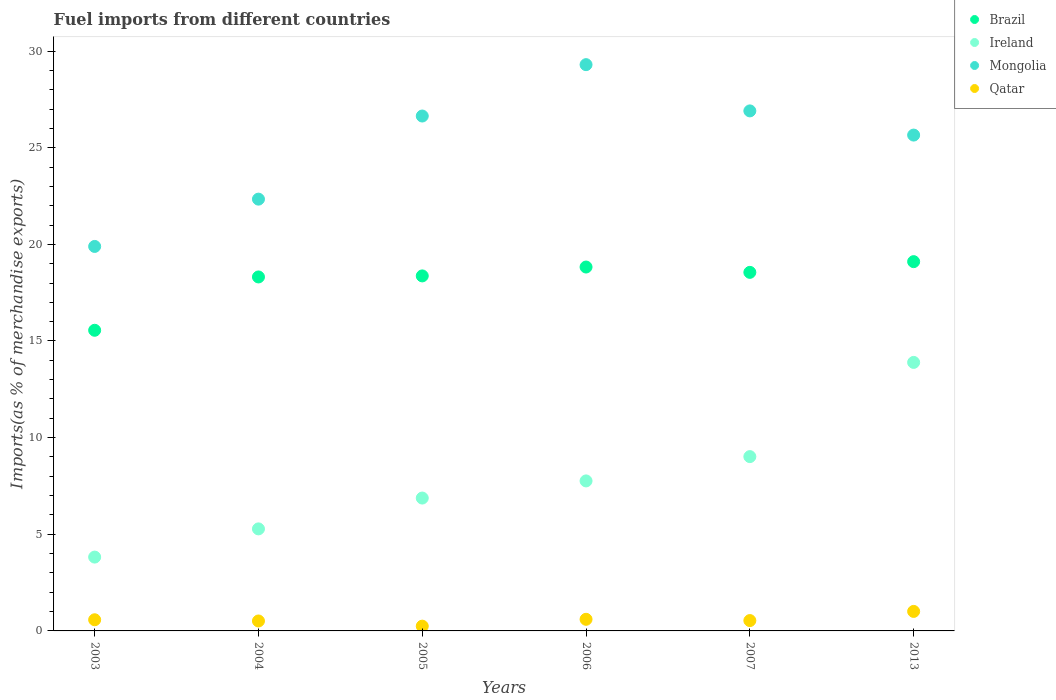How many different coloured dotlines are there?
Offer a terse response. 4. What is the percentage of imports to different countries in Mongolia in 2003?
Keep it short and to the point. 19.89. Across all years, what is the maximum percentage of imports to different countries in Brazil?
Ensure brevity in your answer.  19.1. Across all years, what is the minimum percentage of imports to different countries in Qatar?
Offer a terse response. 0.25. In which year was the percentage of imports to different countries in Ireland maximum?
Keep it short and to the point. 2013. In which year was the percentage of imports to different countries in Qatar minimum?
Provide a short and direct response. 2005. What is the total percentage of imports to different countries in Brazil in the graph?
Provide a succinct answer. 108.72. What is the difference between the percentage of imports to different countries in Mongolia in 2004 and that in 2005?
Make the answer very short. -4.3. What is the difference between the percentage of imports to different countries in Brazil in 2013 and the percentage of imports to different countries in Ireland in 2007?
Offer a very short reply. 10.09. What is the average percentage of imports to different countries in Qatar per year?
Your response must be concise. 0.58. In the year 2007, what is the difference between the percentage of imports to different countries in Brazil and percentage of imports to different countries in Mongolia?
Your answer should be very brief. -8.35. In how many years, is the percentage of imports to different countries in Ireland greater than 9 %?
Make the answer very short. 2. What is the ratio of the percentage of imports to different countries in Qatar in 2003 to that in 2005?
Ensure brevity in your answer.  2.34. Is the percentage of imports to different countries in Mongolia in 2005 less than that in 2006?
Provide a succinct answer. Yes. Is the difference between the percentage of imports to different countries in Brazil in 2003 and 2004 greater than the difference between the percentage of imports to different countries in Mongolia in 2003 and 2004?
Provide a short and direct response. No. What is the difference between the highest and the second highest percentage of imports to different countries in Qatar?
Your answer should be very brief. 0.41. What is the difference between the highest and the lowest percentage of imports to different countries in Mongolia?
Ensure brevity in your answer.  9.41. Is the sum of the percentage of imports to different countries in Qatar in 2004 and 2005 greater than the maximum percentage of imports to different countries in Brazil across all years?
Keep it short and to the point. No. Does the percentage of imports to different countries in Mongolia monotonically increase over the years?
Give a very brief answer. No. Is the percentage of imports to different countries in Ireland strictly greater than the percentage of imports to different countries in Qatar over the years?
Provide a short and direct response. Yes. Is the percentage of imports to different countries in Qatar strictly less than the percentage of imports to different countries in Mongolia over the years?
Provide a short and direct response. Yes. How many dotlines are there?
Offer a terse response. 4. Are the values on the major ticks of Y-axis written in scientific E-notation?
Provide a succinct answer. No. Does the graph contain grids?
Ensure brevity in your answer.  No. How many legend labels are there?
Offer a terse response. 4. How are the legend labels stacked?
Make the answer very short. Vertical. What is the title of the graph?
Ensure brevity in your answer.  Fuel imports from different countries. What is the label or title of the Y-axis?
Give a very brief answer. Imports(as % of merchandise exports). What is the Imports(as % of merchandise exports) of Brazil in 2003?
Give a very brief answer. 15.55. What is the Imports(as % of merchandise exports) in Ireland in 2003?
Make the answer very short. 3.82. What is the Imports(as % of merchandise exports) in Mongolia in 2003?
Your response must be concise. 19.89. What is the Imports(as % of merchandise exports) in Qatar in 2003?
Provide a succinct answer. 0.58. What is the Imports(as % of merchandise exports) of Brazil in 2004?
Your answer should be very brief. 18.31. What is the Imports(as % of merchandise exports) of Ireland in 2004?
Your answer should be compact. 5.28. What is the Imports(as % of merchandise exports) in Mongolia in 2004?
Your answer should be compact. 22.34. What is the Imports(as % of merchandise exports) in Qatar in 2004?
Provide a short and direct response. 0.51. What is the Imports(as % of merchandise exports) in Brazil in 2005?
Ensure brevity in your answer.  18.37. What is the Imports(as % of merchandise exports) in Ireland in 2005?
Your response must be concise. 6.87. What is the Imports(as % of merchandise exports) in Mongolia in 2005?
Offer a terse response. 26.64. What is the Imports(as % of merchandise exports) in Qatar in 2005?
Offer a very short reply. 0.25. What is the Imports(as % of merchandise exports) in Brazil in 2006?
Your answer should be very brief. 18.83. What is the Imports(as % of merchandise exports) in Ireland in 2006?
Your response must be concise. 7.76. What is the Imports(as % of merchandise exports) of Mongolia in 2006?
Give a very brief answer. 29.3. What is the Imports(as % of merchandise exports) in Qatar in 2006?
Ensure brevity in your answer.  0.6. What is the Imports(as % of merchandise exports) of Brazil in 2007?
Your answer should be compact. 18.55. What is the Imports(as % of merchandise exports) of Ireland in 2007?
Keep it short and to the point. 9.02. What is the Imports(as % of merchandise exports) of Mongolia in 2007?
Your answer should be compact. 26.9. What is the Imports(as % of merchandise exports) in Qatar in 2007?
Give a very brief answer. 0.54. What is the Imports(as % of merchandise exports) in Brazil in 2013?
Make the answer very short. 19.1. What is the Imports(as % of merchandise exports) in Ireland in 2013?
Make the answer very short. 13.89. What is the Imports(as % of merchandise exports) of Mongolia in 2013?
Keep it short and to the point. 25.65. What is the Imports(as % of merchandise exports) of Qatar in 2013?
Your answer should be very brief. 1.01. Across all years, what is the maximum Imports(as % of merchandise exports) of Brazil?
Offer a very short reply. 19.1. Across all years, what is the maximum Imports(as % of merchandise exports) in Ireland?
Make the answer very short. 13.89. Across all years, what is the maximum Imports(as % of merchandise exports) in Mongolia?
Your answer should be very brief. 29.3. Across all years, what is the maximum Imports(as % of merchandise exports) of Qatar?
Offer a terse response. 1.01. Across all years, what is the minimum Imports(as % of merchandise exports) of Brazil?
Offer a very short reply. 15.55. Across all years, what is the minimum Imports(as % of merchandise exports) of Ireland?
Your response must be concise. 3.82. Across all years, what is the minimum Imports(as % of merchandise exports) of Mongolia?
Your answer should be very brief. 19.89. Across all years, what is the minimum Imports(as % of merchandise exports) of Qatar?
Ensure brevity in your answer.  0.25. What is the total Imports(as % of merchandise exports) in Brazil in the graph?
Give a very brief answer. 108.72. What is the total Imports(as % of merchandise exports) in Ireland in the graph?
Your answer should be very brief. 46.64. What is the total Imports(as % of merchandise exports) of Mongolia in the graph?
Offer a very short reply. 150.72. What is the total Imports(as % of merchandise exports) of Qatar in the graph?
Offer a terse response. 3.48. What is the difference between the Imports(as % of merchandise exports) in Brazil in 2003 and that in 2004?
Your answer should be very brief. -2.76. What is the difference between the Imports(as % of merchandise exports) of Ireland in 2003 and that in 2004?
Your response must be concise. -1.46. What is the difference between the Imports(as % of merchandise exports) in Mongolia in 2003 and that in 2004?
Provide a succinct answer. -2.45. What is the difference between the Imports(as % of merchandise exports) in Qatar in 2003 and that in 2004?
Your response must be concise. 0.06. What is the difference between the Imports(as % of merchandise exports) in Brazil in 2003 and that in 2005?
Your answer should be very brief. -2.81. What is the difference between the Imports(as % of merchandise exports) of Ireland in 2003 and that in 2005?
Offer a terse response. -3.05. What is the difference between the Imports(as % of merchandise exports) in Mongolia in 2003 and that in 2005?
Give a very brief answer. -6.75. What is the difference between the Imports(as % of merchandise exports) of Qatar in 2003 and that in 2005?
Offer a very short reply. 0.33. What is the difference between the Imports(as % of merchandise exports) of Brazil in 2003 and that in 2006?
Ensure brevity in your answer.  -3.27. What is the difference between the Imports(as % of merchandise exports) of Ireland in 2003 and that in 2006?
Provide a short and direct response. -3.94. What is the difference between the Imports(as % of merchandise exports) in Mongolia in 2003 and that in 2006?
Give a very brief answer. -9.41. What is the difference between the Imports(as % of merchandise exports) in Qatar in 2003 and that in 2006?
Provide a short and direct response. -0.02. What is the difference between the Imports(as % of merchandise exports) in Brazil in 2003 and that in 2007?
Offer a terse response. -3. What is the difference between the Imports(as % of merchandise exports) in Ireland in 2003 and that in 2007?
Provide a short and direct response. -5.2. What is the difference between the Imports(as % of merchandise exports) of Mongolia in 2003 and that in 2007?
Ensure brevity in your answer.  -7.01. What is the difference between the Imports(as % of merchandise exports) in Qatar in 2003 and that in 2007?
Ensure brevity in your answer.  0.04. What is the difference between the Imports(as % of merchandise exports) of Brazil in 2003 and that in 2013?
Give a very brief answer. -3.55. What is the difference between the Imports(as % of merchandise exports) of Ireland in 2003 and that in 2013?
Give a very brief answer. -10.07. What is the difference between the Imports(as % of merchandise exports) of Mongolia in 2003 and that in 2013?
Your answer should be very brief. -5.76. What is the difference between the Imports(as % of merchandise exports) of Qatar in 2003 and that in 2013?
Give a very brief answer. -0.43. What is the difference between the Imports(as % of merchandise exports) in Brazil in 2004 and that in 2005?
Give a very brief answer. -0.05. What is the difference between the Imports(as % of merchandise exports) in Ireland in 2004 and that in 2005?
Provide a short and direct response. -1.59. What is the difference between the Imports(as % of merchandise exports) of Mongolia in 2004 and that in 2005?
Ensure brevity in your answer.  -4.3. What is the difference between the Imports(as % of merchandise exports) of Qatar in 2004 and that in 2005?
Ensure brevity in your answer.  0.27. What is the difference between the Imports(as % of merchandise exports) in Brazil in 2004 and that in 2006?
Ensure brevity in your answer.  -0.51. What is the difference between the Imports(as % of merchandise exports) of Ireland in 2004 and that in 2006?
Keep it short and to the point. -2.48. What is the difference between the Imports(as % of merchandise exports) of Mongolia in 2004 and that in 2006?
Your response must be concise. -6.96. What is the difference between the Imports(as % of merchandise exports) of Qatar in 2004 and that in 2006?
Your response must be concise. -0.09. What is the difference between the Imports(as % of merchandise exports) in Brazil in 2004 and that in 2007?
Your answer should be compact. -0.24. What is the difference between the Imports(as % of merchandise exports) in Ireland in 2004 and that in 2007?
Offer a very short reply. -3.74. What is the difference between the Imports(as % of merchandise exports) of Mongolia in 2004 and that in 2007?
Your answer should be compact. -4.57. What is the difference between the Imports(as % of merchandise exports) of Qatar in 2004 and that in 2007?
Keep it short and to the point. -0.02. What is the difference between the Imports(as % of merchandise exports) of Brazil in 2004 and that in 2013?
Offer a terse response. -0.79. What is the difference between the Imports(as % of merchandise exports) of Ireland in 2004 and that in 2013?
Ensure brevity in your answer.  -8.61. What is the difference between the Imports(as % of merchandise exports) of Mongolia in 2004 and that in 2013?
Your answer should be very brief. -3.31. What is the difference between the Imports(as % of merchandise exports) in Qatar in 2004 and that in 2013?
Provide a succinct answer. -0.49. What is the difference between the Imports(as % of merchandise exports) of Brazil in 2005 and that in 2006?
Offer a very short reply. -0.46. What is the difference between the Imports(as % of merchandise exports) in Ireland in 2005 and that in 2006?
Provide a succinct answer. -0.89. What is the difference between the Imports(as % of merchandise exports) of Mongolia in 2005 and that in 2006?
Your answer should be very brief. -2.66. What is the difference between the Imports(as % of merchandise exports) of Qatar in 2005 and that in 2006?
Provide a short and direct response. -0.35. What is the difference between the Imports(as % of merchandise exports) in Brazil in 2005 and that in 2007?
Provide a succinct answer. -0.18. What is the difference between the Imports(as % of merchandise exports) in Ireland in 2005 and that in 2007?
Make the answer very short. -2.14. What is the difference between the Imports(as % of merchandise exports) of Mongolia in 2005 and that in 2007?
Provide a succinct answer. -0.27. What is the difference between the Imports(as % of merchandise exports) in Qatar in 2005 and that in 2007?
Make the answer very short. -0.29. What is the difference between the Imports(as % of merchandise exports) of Brazil in 2005 and that in 2013?
Offer a terse response. -0.74. What is the difference between the Imports(as % of merchandise exports) of Ireland in 2005 and that in 2013?
Provide a short and direct response. -7.02. What is the difference between the Imports(as % of merchandise exports) of Mongolia in 2005 and that in 2013?
Give a very brief answer. 0.99. What is the difference between the Imports(as % of merchandise exports) of Qatar in 2005 and that in 2013?
Provide a succinct answer. -0.76. What is the difference between the Imports(as % of merchandise exports) in Brazil in 2006 and that in 2007?
Offer a very short reply. 0.28. What is the difference between the Imports(as % of merchandise exports) in Ireland in 2006 and that in 2007?
Your response must be concise. -1.26. What is the difference between the Imports(as % of merchandise exports) in Mongolia in 2006 and that in 2007?
Ensure brevity in your answer.  2.39. What is the difference between the Imports(as % of merchandise exports) of Qatar in 2006 and that in 2007?
Your answer should be compact. 0.07. What is the difference between the Imports(as % of merchandise exports) in Brazil in 2006 and that in 2013?
Make the answer very short. -0.28. What is the difference between the Imports(as % of merchandise exports) in Ireland in 2006 and that in 2013?
Keep it short and to the point. -6.13. What is the difference between the Imports(as % of merchandise exports) of Mongolia in 2006 and that in 2013?
Your answer should be compact. 3.64. What is the difference between the Imports(as % of merchandise exports) in Qatar in 2006 and that in 2013?
Make the answer very short. -0.41. What is the difference between the Imports(as % of merchandise exports) in Brazil in 2007 and that in 2013?
Your response must be concise. -0.55. What is the difference between the Imports(as % of merchandise exports) in Ireland in 2007 and that in 2013?
Provide a succinct answer. -4.87. What is the difference between the Imports(as % of merchandise exports) of Mongolia in 2007 and that in 2013?
Provide a succinct answer. 1.25. What is the difference between the Imports(as % of merchandise exports) of Qatar in 2007 and that in 2013?
Offer a very short reply. -0.47. What is the difference between the Imports(as % of merchandise exports) of Brazil in 2003 and the Imports(as % of merchandise exports) of Ireland in 2004?
Your response must be concise. 10.28. What is the difference between the Imports(as % of merchandise exports) in Brazil in 2003 and the Imports(as % of merchandise exports) in Mongolia in 2004?
Ensure brevity in your answer.  -6.78. What is the difference between the Imports(as % of merchandise exports) of Brazil in 2003 and the Imports(as % of merchandise exports) of Qatar in 2004?
Give a very brief answer. 15.04. What is the difference between the Imports(as % of merchandise exports) in Ireland in 2003 and the Imports(as % of merchandise exports) in Mongolia in 2004?
Make the answer very short. -18.52. What is the difference between the Imports(as % of merchandise exports) in Ireland in 2003 and the Imports(as % of merchandise exports) in Qatar in 2004?
Give a very brief answer. 3.31. What is the difference between the Imports(as % of merchandise exports) in Mongolia in 2003 and the Imports(as % of merchandise exports) in Qatar in 2004?
Ensure brevity in your answer.  19.38. What is the difference between the Imports(as % of merchandise exports) in Brazil in 2003 and the Imports(as % of merchandise exports) in Ireland in 2005?
Offer a very short reply. 8.68. What is the difference between the Imports(as % of merchandise exports) of Brazil in 2003 and the Imports(as % of merchandise exports) of Mongolia in 2005?
Your answer should be very brief. -11.08. What is the difference between the Imports(as % of merchandise exports) of Brazil in 2003 and the Imports(as % of merchandise exports) of Qatar in 2005?
Ensure brevity in your answer.  15.31. What is the difference between the Imports(as % of merchandise exports) of Ireland in 2003 and the Imports(as % of merchandise exports) of Mongolia in 2005?
Your answer should be compact. -22.82. What is the difference between the Imports(as % of merchandise exports) of Ireland in 2003 and the Imports(as % of merchandise exports) of Qatar in 2005?
Make the answer very short. 3.57. What is the difference between the Imports(as % of merchandise exports) in Mongolia in 2003 and the Imports(as % of merchandise exports) in Qatar in 2005?
Provide a short and direct response. 19.65. What is the difference between the Imports(as % of merchandise exports) of Brazil in 2003 and the Imports(as % of merchandise exports) of Ireland in 2006?
Provide a succinct answer. 7.79. What is the difference between the Imports(as % of merchandise exports) in Brazil in 2003 and the Imports(as % of merchandise exports) in Mongolia in 2006?
Your answer should be very brief. -13.74. What is the difference between the Imports(as % of merchandise exports) in Brazil in 2003 and the Imports(as % of merchandise exports) in Qatar in 2006?
Offer a very short reply. 14.95. What is the difference between the Imports(as % of merchandise exports) in Ireland in 2003 and the Imports(as % of merchandise exports) in Mongolia in 2006?
Give a very brief answer. -25.48. What is the difference between the Imports(as % of merchandise exports) of Ireland in 2003 and the Imports(as % of merchandise exports) of Qatar in 2006?
Your answer should be very brief. 3.22. What is the difference between the Imports(as % of merchandise exports) in Mongolia in 2003 and the Imports(as % of merchandise exports) in Qatar in 2006?
Keep it short and to the point. 19.29. What is the difference between the Imports(as % of merchandise exports) of Brazil in 2003 and the Imports(as % of merchandise exports) of Ireland in 2007?
Your response must be concise. 6.54. What is the difference between the Imports(as % of merchandise exports) of Brazil in 2003 and the Imports(as % of merchandise exports) of Mongolia in 2007?
Offer a very short reply. -11.35. What is the difference between the Imports(as % of merchandise exports) in Brazil in 2003 and the Imports(as % of merchandise exports) in Qatar in 2007?
Keep it short and to the point. 15.02. What is the difference between the Imports(as % of merchandise exports) of Ireland in 2003 and the Imports(as % of merchandise exports) of Mongolia in 2007?
Your response must be concise. -23.08. What is the difference between the Imports(as % of merchandise exports) of Ireland in 2003 and the Imports(as % of merchandise exports) of Qatar in 2007?
Your answer should be compact. 3.28. What is the difference between the Imports(as % of merchandise exports) of Mongolia in 2003 and the Imports(as % of merchandise exports) of Qatar in 2007?
Keep it short and to the point. 19.36. What is the difference between the Imports(as % of merchandise exports) in Brazil in 2003 and the Imports(as % of merchandise exports) in Ireland in 2013?
Provide a succinct answer. 1.66. What is the difference between the Imports(as % of merchandise exports) in Brazil in 2003 and the Imports(as % of merchandise exports) in Mongolia in 2013?
Ensure brevity in your answer.  -10.1. What is the difference between the Imports(as % of merchandise exports) of Brazil in 2003 and the Imports(as % of merchandise exports) of Qatar in 2013?
Provide a short and direct response. 14.54. What is the difference between the Imports(as % of merchandise exports) in Ireland in 2003 and the Imports(as % of merchandise exports) in Mongolia in 2013?
Offer a terse response. -21.83. What is the difference between the Imports(as % of merchandise exports) of Ireland in 2003 and the Imports(as % of merchandise exports) of Qatar in 2013?
Offer a terse response. 2.81. What is the difference between the Imports(as % of merchandise exports) of Mongolia in 2003 and the Imports(as % of merchandise exports) of Qatar in 2013?
Ensure brevity in your answer.  18.88. What is the difference between the Imports(as % of merchandise exports) in Brazil in 2004 and the Imports(as % of merchandise exports) in Ireland in 2005?
Provide a short and direct response. 11.44. What is the difference between the Imports(as % of merchandise exports) in Brazil in 2004 and the Imports(as % of merchandise exports) in Mongolia in 2005?
Offer a terse response. -8.33. What is the difference between the Imports(as % of merchandise exports) of Brazil in 2004 and the Imports(as % of merchandise exports) of Qatar in 2005?
Give a very brief answer. 18.07. What is the difference between the Imports(as % of merchandise exports) in Ireland in 2004 and the Imports(as % of merchandise exports) in Mongolia in 2005?
Offer a very short reply. -21.36. What is the difference between the Imports(as % of merchandise exports) of Ireland in 2004 and the Imports(as % of merchandise exports) of Qatar in 2005?
Give a very brief answer. 5.03. What is the difference between the Imports(as % of merchandise exports) in Mongolia in 2004 and the Imports(as % of merchandise exports) in Qatar in 2005?
Ensure brevity in your answer.  22.09. What is the difference between the Imports(as % of merchandise exports) of Brazil in 2004 and the Imports(as % of merchandise exports) of Ireland in 2006?
Your response must be concise. 10.55. What is the difference between the Imports(as % of merchandise exports) in Brazil in 2004 and the Imports(as % of merchandise exports) in Mongolia in 2006?
Offer a very short reply. -10.98. What is the difference between the Imports(as % of merchandise exports) of Brazil in 2004 and the Imports(as % of merchandise exports) of Qatar in 2006?
Ensure brevity in your answer.  17.71. What is the difference between the Imports(as % of merchandise exports) of Ireland in 2004 and the Imports(as % of merchandise exports) of Mongolia in 2006?
Your answer should be very brief. -24.02. What is the difference between the Imports(as % of merchandise exports) in Ireland in 2004 and the Imports(as % of merchandise exports) in Qatar in 2006?
Ensure brevity in your answer.  4.68. What is the difference between the Imports(as % of merchandise exports) of Mongolia in 2004 and the Imports(as % of merchandise exports) of Qatar in 2006?
Your response must be concise. 21.74. What is the difference between the Imports(as % of merchandise exports) in Brazil in 2004 and the Imports(as % of merchandise exports) in Ireland in 2007?
Make the answer very short. 9.29. What is the difference between the Imports(as % of merchandise exports) of Brazil in 2004 and the Imports(as % of merchandise exports) of Mongolia in 2007?
Make the answer very short. -8.59. What is the difference between the Imports(as % of merchandise exports) in Brazil in 2004 and the Imports(as % of merchandise exports) in Qatar in 2007?
Offer a very short reply. 17.78. What is the difference between the Imports(as % of merchandise exports) of Ireland in 2004 and the Imports(as % of merchandise exports) of Mongolia in 2007?
Your answer should be very brief. -21.63. What is the difference between the Imports(as % of merchandise exports) in Ireland in 2004 and the Imports(as % of merchandise exports) in Qatar in 2007?
Ensure brevity in your answer.  4.74. What is the difference between the Imports(as % of merchandise exports) in Mongolia in 2004 and the Imports(as % of merchandise exports) in Qatar in 2007?
Your response must be concise. 21.8. What is the difference between the Imports(as % of merchandise exports) of Brazil in 2004 and the Imports(as % of merchandise exports) of Ireland in 2013?
Give a very brief answer. 4.42. What is the difference between the Imports(as % of merchandise exports) in Brazil in 2004 and the Imports(as % of merchandise exports) in Mongolia in 2013?
Provide a succinct answer. -7.34. What is the difference between the Imports(as % of merchandise exports) of Brazil in 2004 and the Imports(as % of merchandise exports) of Qatar in 2013?
Your answer should be very brief. 17.3. What is the difference between the Imports(as % of merchandise exports) in Ireland in 2004 and the Imports(as % of merchandise exports) in Mongolia in 2013?
Your answer should be very brief. -20.37. What is the difference between the Imports(as % of merchandise exports) of Ireland in 2004 and the Imports(as % of merchandise exports) of Qatar in 2013?
Offer a terse response. 4.27. What is the difference between the Imports(as % of merchandise exports) in Mongolia in 2004 and the Imports(as % of merchandise exports) in Qatar in 2013?
Provide a short and direct response. 21.33. What is the difference between the Imports(as % of merchandise exports) of Brazil in 2005 and the Imports(as % of merchandise exports) of Ireland in 2006?
Your response must be concise. 10.61. What is the difference between the Imports(as % of merchandise exports) in Brazil in 2005 and the Imports(as % of merchandise exports) in Mongolia in 2006?
Your response must be concise. -10.93. What is the difference between the Imports(as % of merchandise exports) of Brazil in 2005 and the Imports(as % of merchandise exports) of Qatar in 2006?
Your answer should be very brief. 17.77. What is the difference between the Imports(as % of merchandise exports) in Ireland in 2005 and the Imports(as % of merchandise exports) in Mongolia in 2006?
Offer a terse response. -22.42. What is the difference between the Imports(as % of merchandise exports) of Ireland in 2005 and the Imports(as % of merchandise exports) of Qatar in 2006?
Offer a terse response. 6.27. What is the difference between the Imports(as % of merchandise exports) of Mongolia in 2005 and the Imports(as % of merchandise exports) of Qatar in 2006?
Provide a succinct answer. 26.04. What is the difference between the Imports(as % of merchandise exports) of Brazil in 2005 and the Imports(as % of merchandise exports) of Ireland in 2007?
Your response must be concise. 9.35. What is the difference between the Imports(as % of merchandise exports) of Brazil in 2005 and the Imports(as % of merchandise exports) of Mongolia in 2007?
Offer a terse response. -8.54. What is the difference between the Imports(as % of merchandise exports) of Brazil in 2005 and the Imports(as % of merchandise exports) of Qatar in 2007?
Your answer should be compact. 17.83. What is the difference between the Imports(as % of merchandise exports) of Ireland in 2005 and the Imports(as % of merchandise exports) of Mongolia in 2007?
Provide a succinct answer. -20.03. What is the difference between the Imports(as % of merchandise exports) of Ireland in 2005 and the Imports(as % of merchandise exports) of Qatar in 2007?
Your response must be concise. 6.34. What is the difference between the Imports(as % of merchandise exports) of Mongolia in 2005 and the Imports(as % of merchandise exports) of Qatar in 2007?
Offer a very short reply. 26.1. What is the difference between the Imports(as % of merchandise exports) in Brazil in 2005 and the Imports(as % of merchandise exports) in Ireland in 2013?
Your answer should be very brief. 4.48. What is the difference between the Imports(as % of merchandise exports) in Brazil in 2005 and the Imports(as % of merchandise exports) in Mongolia in 2013?
Make the answer very short. -7.29. What is the difference between the Imports(as % of merchandise exports) in Brazil in 2005 and the Imports(as % of merchandise exports) in Qatar in 2013?
Make the answer very short. 17.36. What is the difference between the Imports(as % of merchandise exports) of Ireland in 2005 and the Imports(as % of merchandise exports) of Mongolia in 2013?
Your answer should be very brief. -18.78. What is the difference between the Imports(as % of merchandise exports) in Ireland in 2005 and the Imports(as % of merchandise exports) in Qatar in 2013?
Offer a very short reply. 5.86. What is the difference between the Imports(as % of merchandise exports) in Mongolia in 2005 and the Imports(as % of merchandise exports) in Qatar in 2013?
Your answer should be compact. 25.63. What is the difference between the Imports(as % of merchandise exports) in Brazil in 2006 and the Imports(as % of merchandise exports) in Ireland in 2007?
Provide a succinct answer. 9.81. What is the difference between the Imports(as % of merchandise exports) of Brazil in 2006 and the Imports(as % of merchandise exports) of Mongolia in 2007?
Keep it short and to the point. -8.08. What is the difference between the Imports(as % of merchandise exports) in Brazil in 2006 and the Imports(as % of merchandise exports) in Qatar in 2007?
Ensure brevity in your answer.  18.29. What is the difference between the Imports(as % of merchandise exports) in Ireland in 2006 and the Imports(as % of merchandise exports) in Mongolia in 2007?
Give a very brief answer. -19.14. What is the difference between the Imports(as % of merchandise exports) of Ireland in 2006 and the Imports(as % of merchandise exports) of Qatar in 2007?
Offer a very short reply. 7.22. What is the difference between the Imports(as % of merchandise exports) of Mongolia in 2006 and the Imports(as % of merchandise exports) of Qatar in 2007?
Provide a short and direct response. 28.76. What is the difference between the Imports(as % of merchandise exports) in Brazil in 2006 and the Imports(as % of merchandise exports) in Ireland in 2013?
Offer a very short reply. 4.93. What is the difference between the Imports(as % of merchandise exports) of Brazil in 2006 and the Imports(as % of merchandise exports) of Mongolia in 2013?
Make the answer very short. -6.83. What is the difference between the Imports(as % of merchandise exports) of Brazil in 2006 and the Imports(as % of merchandise exports) of Qatar in 2013?
Provide a succinct answer. 17.82. What is the difference between the Imports(as % of merchandise exports) in Ireland in 2006 and the Imports(as % of merchandise exports) in Mongolia in 2013?
Give a very brief answer. -17.89. What is the difference between the Imports(as % of merchandise exports) in Ireland in 2006 and the Imports(as % of merchandise exports) in Qatar in 2013?
Make the answer very short. 6.75. What is the difference between the Imports(as % of merchandise exports) of Mongolia in 2006 and the Imports(as % of merchandise exports) of Qatar in 2013?
Make the answer very short. 28.29. What is the difference between the Imports(as % of merchandise exports) of Brazil in 2007 and the Imports(as % of merchandise exports) of Ireland in 2013?
Ensure brevity in your answer.  4.66. What is the difference between the Imports(as % of merchandise exports) of Brazil in 2007 and the Imports(as % of merchandise exports) of Mongolia in 2013?
Make the answer very short. -7.1. What is the difference between the Imports(as % of merchandise exports) of Brazil in 2007 and the Imports(as % of merchandise exports) of Qatar in 2013?
Provide a succinct answer. 17.54. What is the difference between the Imports(as % of merchandise exports) of Ireland in 2007 and the Imports(as % of merchandise exports) of Mongolia in 2013?
Make the answer very short. -16.63. What is the difference between the Imports(as % of merchandise exports) of Ireland in 2007 and the Imports(as % of merchandise exports) of Qatar in 2013?
Provide a short and direct response. 8.01. What is the difference between the Imports(as % of merchandise exports) of Mongolia in 2007 and the Imports(as % of merchandise exports) of Qatar in 2013?
Your answer should be very brief. 25.89. What is the average Imports(as % of merchandise exports) in Brazil per year?
Provide a succinct answer. 18.12. What is the average Imports(as % of merchandise exports) of Ireland per year?
Offer a terse response. 7.77. What is the average Imports(as % of merchandise exports) in Mongolia per year?
Your answer should be compact. 25.12. What is the average Imports(as % of merchandise exports) of Qatar per year?
Your answer should be very brief. 0.58. In the year 2003, what is the difference between the Imports(as % of merchandise exports) in Brazil and Imports(as % of merchandise exports) in Ireland?
Your answer should be very brief. 11.73. In the year 2003, what is the difference between the Imports(as % of merchandise exports) in Brazil and Imports(as % of merchandise exports) in Mongolia?
Make the answer very short. -4.34. In the year 2003, what is the difference between the Imports(as % of merchandise exports) of Brazil and Imports(as % of merchandise exports) of Qatar?
Give a very brief answer. 14.98. In the year 2003, what is the difference between the Imports(as % of merchandise exports) in Ireland and Imports(as % of merchandise exports) in Mongolia?
Make the answer very short. -16.07. In the year 2003, what is the difference between the Imports(as % of merchandise exports) in Ireland and Imports(as % of merchandise exports) in Qatar?
Keep it short and to the point. 3.24. In the year 2003, what is the difference between the Imports(as % of merchandise exports) in Mongolia and Imports(as % of merchandise exports) in Qatar?
Offer a very short reply. 19.31. In the year 2004, what is the difference between the Imports(as % of merchandise exports) in Brazil and Imports(as % of merchandise exports) in Ireland?
Ensure brevity in your answer.  13.03. In the year 2004, what is the difference between the Imports(as % of merchandise exports) of Brazil and Imports(as % of merchandise exports) of Mongolia?
Make the answer very short. -4.03. In the year 2004, what is the difference between the Imports(as % of merchandise exports) of Brazil and Imports(as % of merchandise exports) of Qatar?
Give a very brief answer. 17.8. In the year 2004, what is the difference between the Imports(as % of merchandise exports) in Ireland and Imports(as % of merchandise exports) in Mongolia?
Keep it short and to the point. -17.06. In the year 2004, what is the difference between the Imports(as % of merchandise exports) of Ireland and Imports(as % of merchandise exports) of Qatar?
Make the answer very short. 4.76. In the year 2004, what is the difference between the Imports(as % of merchandise exports) of Mongolia and Imports(as % of merchandise exports) of Qatar?
Ensure brevity in your answer.  21.82. In the year 2005, what is the difference between the Imports(as % of merchandise exports) of Brazil and Imports(as % of merchandise exports) of Ireland?
Your answer should be very brief. 11.49. In the year 2005, what is the difference between the Imports(as % of merchandise exports) in Brazil and Imports(as % of merchandise exports) in Mongolia?
Your answer should be very brief. -8.27. In the year 2005, what is the difference between the Imports(as % of merchandise exports) of Brazil and Imports(as % of merchandise exports) of Qatar?
Keep it short and to the point. 18.12. In the year 2005, what is the difference between the Imports(as % of merchandise exports) in Ireland and Imports(as % of merchandise exports) in Mongolia?
Offer a very short reply. -19.76. In the year 2005, what is the difference between the Imports(as % of merchandise exports) in Ireland and Imports(as % of merchandise exports) in Qatar?
Ensure brevity in your answer.  6.63. In the year 2005, what is the difference between the Imports(as % of merchandise exports) in Mongolia and Imports(as % of merchandise exports) in Qatar?
Offer a terse response. 26.39. In the year 2006, what is the difference between the Imports(as % of merchandise exports) of Brazil and Imports(as % of merchandise exports) of Ireland?
Offer a very short reply. 11.07. In the year 2006, what is the difference between the Imports(as % of merchandise exports) in Brazil and Imports(as % of merchandise exports) in Mongolia?
Provide a succinct answer. -10.47. In the year 2006, what is the difference between the Imports(as % of merchandise exports) in Brazil and Imports(as % of merchandise exports) in Qatar?
Your answer should be very brief. 18.23. In the year 2006, what is the difference between the Imports(as % of merchandise exports) in Ireland and Imports(as % of merchandise exports) in Mongolia?
Your answer should be compact. -21.54. In the year 2006, what is the difference between the Imports(as % of merchandise exports) of Ireland and Imports(as % of merchandise exports) of Qatar?
Give a very brief answer. 7.16. In the year 2006, what is the difference between the Imports(as % of merchandise exports) in Mongolia and Imports(as % of merchandise exports) in Qatar?
Give a very brief answer. 28.7. In the year 2007, what is the difference between the Imports(as % of merchandise exports) of Brazil and Imports(as % of merchandise exports) of Ireland?
Ensure brevity in your answer.  9.53. In the year 2007, what is the difference between the Imports(as % of merchandise exports) in Brazil and Imports(as % of merchandise exports) in Mongolia?
Provide a succinct answer. -8.35. In the year 2007, what is the difference between the Imports(as % of merchandise exports) in Brazil and Imports(as % of merchandise exports) in Qatar?
Your answer should be very brief. 18.01. In the year 2007, what is the difference between the Imports(as % of merchandise exports) in Ireland and Imports(as % of merchandise exports) in Mongolia?
Ensure brevity in your answer.  -17.89. In the year 2007, what is the difference between the Imports(as % of merchandise exports) of Ireland and Imports(as % of merchandise exports) of Qatar?
Offer a terse response. 8.48. In the year 2007, what is the difference between the Imports(as % of merchandise exports) in Mongolia and Imports(as % of merchandise exports) in Qatar?
Offer a very short reply. 26.37. In the year 2013, what is the difference between the Imports(as % of merchandise exports) of Brazil and Imports(as % of merchandise exports) of Ireland?
Ensure brevity in your answer.  5.21. In the year 2013, what is the difference between the Imports(as % of merchandise exports) in Brazil and Imports(as % of merchandise exports) in Mongolia?
Provide a short and direct response. -6.55. In the year 2013, what is the difference between the Imports(as % of merchandise exports) in Brazil and Imports(as % of merchandise exports) in Qatar?
Your answer should be very brief. 18.1. In the year 2013, what is the difference between the Imports(as % of merchandise exports) of Ireland and Imports(as % of merchandise exports) of Mongolia?
Provide a short and direct response. -11.76. In the year 2013, what is the difference between the Imports(as % of merchandise exports) in Ireland and Imports(as % of merchandise exports) in Qatar?
Your answer should be very brief. 12.88. In the year 2013, what is the difference between the Imports(as % of merchandise exports) of Mongolia and Imports(as % of merchandise exports) of Qatar?
Your answer should be very brief. 24.64. What is the ratio of the Imports(as % of merchandise exports) in Brazil in 2003 to that in 2004?
Your answer should be compact. 0.85. What is the ratio of the Imports(as % of merchandise exports) of Ireland in 2003 to that in 2004?
Give a very brief answer. 0.72. What is the ratio of the Imports(as % of merchandise exports) in Mongolia in 2003 to that in 2004?
Provide a short and direct response. 0.89. What is the ratio of the Imports(as % of merchandise exports) in Qatar in 2003 to that in 2004?
Keep it short and to the point. 1.12. What is the ratio of the Imports(as % of merchandise exports) of Brazil in 2003 to that in 2005?
Your response must be concise. 0.85. What is the ratio of the Imports(as % of merchandise exports) of Ireland in 2003 to that in 2005?
Ensure brevity in your answer.  0.56. What is the ratio of the Imports(as % of merchandise exports) of Mongolia in 2003 to that in 2005?
Provide a succinct answer. 0.75. What is the ratio of the Imports(as % of merchandise exports) in Qatar in 2003 to that in 2005?
Provide a short and direct response. 2.34. What is the ratio of the Imports(as % of merchandise exports) of Brazil in 2003 to that in 2006?
Your answer should be compact. 0.83. What is the ratio of the Imports(as % of merchandise exports) of Ireland in 2003 to that in 2006?
Your response must be concise. 0.49. What is the ratio of the Imports(as % of merchandise exports) of Mongolia in 2003 to that in 2006?
Your response must be concise. 0.68. What is the ratio of the Imports(as % of merchandise exports) of Qatar in 2003 to that in 2006?
Provide a succinct answer. 0.96. What is the ratio of the Imports(as % of merchandise exports) in Brazil in 2003 to that in 2007?
Your response must be concise. 0.84. What is the ratio of the Imports(as % of merchandise exports) in Ireland in 2003 to that in 2007?
Keep it short and to the point. 0.42. What is the ratio of the Imports(as % of merchandise exports) of Mongolia in 2003 to that in 2007?
Your answer should be very brief. 0.74. What is the ratio of the Imports(as % of merchandise exports) of Qatar in 2003 to that in 2007?
Make the answer very short. 1.08. What is the ratio of the Imports(as % of merchandise exports) in Brazil in 2003 to that in 2013?
Keep it short and to the point. 0.81. What is the ratio of the Imports(as % of merchandise exports) in Ireland in 2003 to that in 2013?
Offer a terse response. 0.28. What is the ratio of the Imports(as % of merchandise exports) of Mongolia in 2003 to that in 2013?
Provide a short and direct response. 0.78. What is the ratio of the Imports(as % of merchandise exports) in Qatar in 2003 to that in 2013?
Offer a terse response. 0.57. What is the ratio of the Imports(as % of merchandise exports) in Brazil in 2004 to that in 2005?
Your answer should be very brief. 1. What is the ratio of the Imports(as % of merchandise exports) in Ireland in 2004 to that in 2005?
Your answer should be compact. 0.77. What is the ratio of the Imports(as % of merchandise exports) of Mongolia in 2004 to that in 2005?
Offer a terse response. 0.84. What is the ratio of the Imports(as % of merchandise exports) of Qatar in 2004 to that in 2005?
Offer a terse response. 2.09. What is the ratio of the Imports(as % of merchandise exports) of Brazil in 2004 to that in 2006?
Give a very brief answer. 0.97. What is the ratio of the Imports(as % of merchandise exports) in Ireland in 2004 to that in 2006?
Provide a succinct answer. 0.68. What is the ratio of the Imports(as % of merchandise exports) in Mongolia in 2004 to that in 2006?
Ensure brevity in your answer.  0.76. What is the ratio of the Imports(as % of merchandise exports) of Qatar in 2004 to that in 2006?
Give a very brief answer. 0.86. What is the ratio of the Imports(as % of merchandise exports) in Brazil in 2004 to that in 2007?
Give a very brief answer. 0.99. What is the ratio of the Imports(as % of merchandise exports) of Ireland in 2004 to that in 2007?
Your answer should be compact. 0.59. What is the ratio of the Imports(as % of merchandise exports) of Mongolia in 2004 to that in 2007?
Give a very brief answer. 0.83. What is the ratio of the Imports(as % of merchandise exports) in Qatar in 2004 to that in 2007?
Offer a very short reply. 0.96. What is the ratio of the Imports(as % of merchandise exports) of Brazil in 2004 to that in 2013?
Ensure brevity in your answer.  0.96. What is the ratio of the Imports(as % of merchandise exports) in Ireland in 2004 to that in 2013?
Your answer should be compact. 0.38. What is the ratio of the Imports(as % of merchandise exports) in Mongolia in 2004 to that in 2013?
Ensure brevity in your answer.  0.87. What is the ratio of the Imports(as % of merchandise exports) in Qatar in 2004 to that in 2013?
Keep it short and to the point. 0.51. What is the ratio of the Imports(as % of merchandise exports) in Brazil in 2005 to that in 2006?
Ensure brevity in your answer.  0.98. What is the ratio of the Imports(as % of merchandise exports) of Ireland in 2005 to that in 2006?
Provide a succinct answer. 0.89. What is the ratio of the Imports(as % of merchandise exports) in Mongolia in 2005 to that in 2006?
Make the answer very short. 0.91. What is the ratio of the Imports(as % of merchandise exports) of Qatar in 2005 to that in 2006?
Offer a very short reply. 0.41. What is the ratio of the Imports(as % of merchandise exports) in Brazil in 2005 to that in 2007?
Ensure brevity in your answer.  0.99. What is the ratio of the Imports(as % of merchandise exports) in Ireland in 2005 to that in 2007?
Your response must be concise. 0.76. What is the ratio of the Imports(as % of merchandise exports) of Qatar in 2005 to that in 2007?
Provide a succinct answer. 0.46. What is the ratio of the Imports(as % of merchandise exports) in Brazil in 2005 to that in 2013?
Offer a terse response. 0.96. What is the ratio of the Imports(as % of merchandise exports) in Ireland in 2005 to that in 2013?
Keep it short and to the point. 0.49. What is the ratio of the Imports(as % of merchandise exports) in Mongolia in 2005 to that in 2013?
Your response must be concise. 1.04. What is the ratio of the Imports(as % of merchandise exports) of Qatar in 2005 to that in 2013?
Your answer should be compact. 0.24. What is the ratio of the Imports(as % of merchandise exports) in Brazil in 2006 to that in 2007?
Give a very brief answer. 1.01. What is the ratio of the Imports(as % of merchandise exports) of Ireland in 2006 to that in 2007?
Offer a terse response. 0.86. What is the ratio of the Imports(as % of merchandise exports) of Mongolia in 2006 to that in 2007?
Your answer should be very brief. 1.09. What is the ratio of the Imports(as % of merchandise exports) of Qatar in 2006 to that in 2007?
Provide a succinct answer. 1.12. What is the ratio of the Imports(as % of merchandise exports) in Brazil in 2006 to that in 2013?
Ensure brevity in your answer.  0.99. What is the ratio of the Imports(as % of merchandise exports) in Ireland in 2006 to that in 2013?
Your answer should be very brief. 0.56. What is the ratio of the Imports(as % of merchandise exports) of Mongolia in 2006 to that in 2013?
Keep it short and to the point. 1.14. What is the ratio of the Imports(as % of merchandise exports) in Qatar in 2006 to that in 2013?
Give a very brief answer. 0.6. What is the ratio of the Imports(as % of merchandise exports) in Ireland in 2007 to that in 2013?
Provide a succinct answer. 0.65. What is the ratio of the Imports(as % of merchandise exports) in Mongolia in 2007 to that in 2013?
Offer a terse response. 1.05. What is the ratio of the Imports(as % of merchandise exports) in Qatar in 2007 to that in 2013?
Keep it short and to the point. 0.53. What is the difference between the highest and the second highest Imports(as % of merchandise exports) of Brazil?
Provide a succinct answer. 0.28. What is the difference between the highest and the second highest Imports(as % of merchandise exports) of Ireland?
Make the answer very short. 4.87. What is the difference between the highest and the second highest Imports(as % of merchandise exports) of Mongolia?
Offer a terse response. 2.39. What is the difference between the highest and the second highest Imports(as % of merchandise exports) in Qatar?
Your answer should be compact. 0.41. What is the difference between the highest and the lowest Imports(as % of merchandise exports) of Brazil?
Make the answer very short. 3.55. What is the difference between the highest and the lowest Imports(as % of merchandise exports) in Ireland?
Keep it short and to the point. 10.07. What is the difference between the highest and the lowest Imports(as % of merchandise exports) of Mongolia?
Offer a very short reply. 9.41. What is the difference between the highest and the lowest Imports(as % of merchandise exports) of Qatar?
Offer a very short reply. 0.76. 